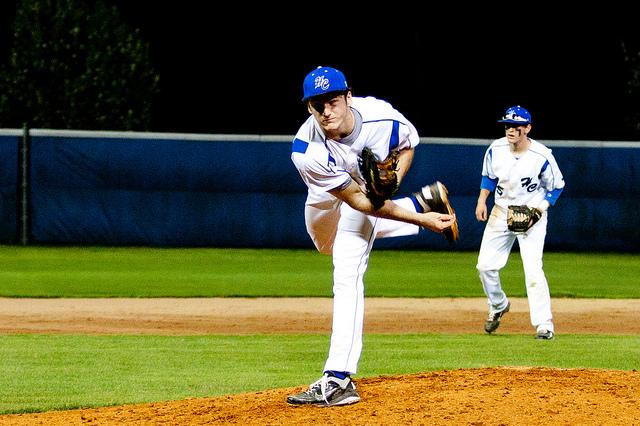Why does the man stand on one leg? pitching 